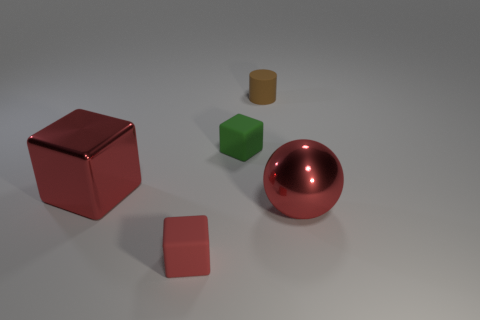What is the material of the small cube that is the same color as the big metal block?
Your answer should be compact. Rubber. Does the red ball in front of the big red block have the same material as the small cube on the right side of the red matte block?
Give a very brief answer. No. Are there any tiny gray matte objects?
Give a very brief answer. No. Are there more large red shiny things that are in front of the small green matte object than large red shiny balls that are in front of the large metal sphere?
Your answer should be compact. Yes. There is a tiny red object that is the same shape as the small green matte object; what is its material?
Ensure brevity in your answer.  Rubber. Is there anything else that is the same size as the green rubber block?
Your answer should be very brief. Yes. There is a block that is in front of the red metal cube; does it have the same color as the large shiny object right of the tiny cylinder?
Provide a short and direct response. Yes. What is the shape of the small brown rubber thing?
Give a very brief answer. Cylinder. Is the number of brown things that are behind the small green rubber object greater than the number of yellow shiny balls?
Your response must be concise. Yes. There is a shiny thing that is to the left of the small brown thing; what shape is it?
Provide a short and direct response. Cube. 